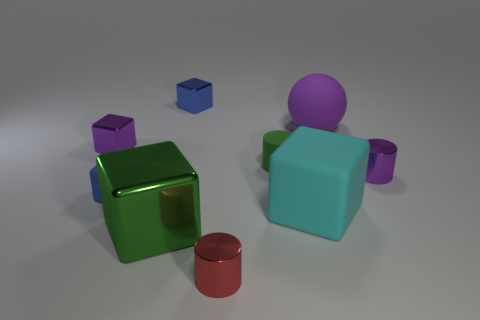Add 1 big purple objects. How many objects exist? 10 Subtract all small purple metal cylinders. How many cylinders are left? 2 Subtract all gray spheres. How many blue cubes are left? 2 Subtract all green blocks. How many blocks are left? 4 Subtract 1 cubes. How many cubes are left? 4 Subtract 1 green cylinders. How many objects are left? 8 Subtract all cubes. How many objects are left? 4 Subtract all green cubes. Subtract all yellow spheres. How many cubes are left? 4 Subtract all cyan matte cubes. Subtract all green matte things. How many objects are left? 7 Add 4 tiny blue rubber objects. How many tiny blue rubber objects are left? 5 